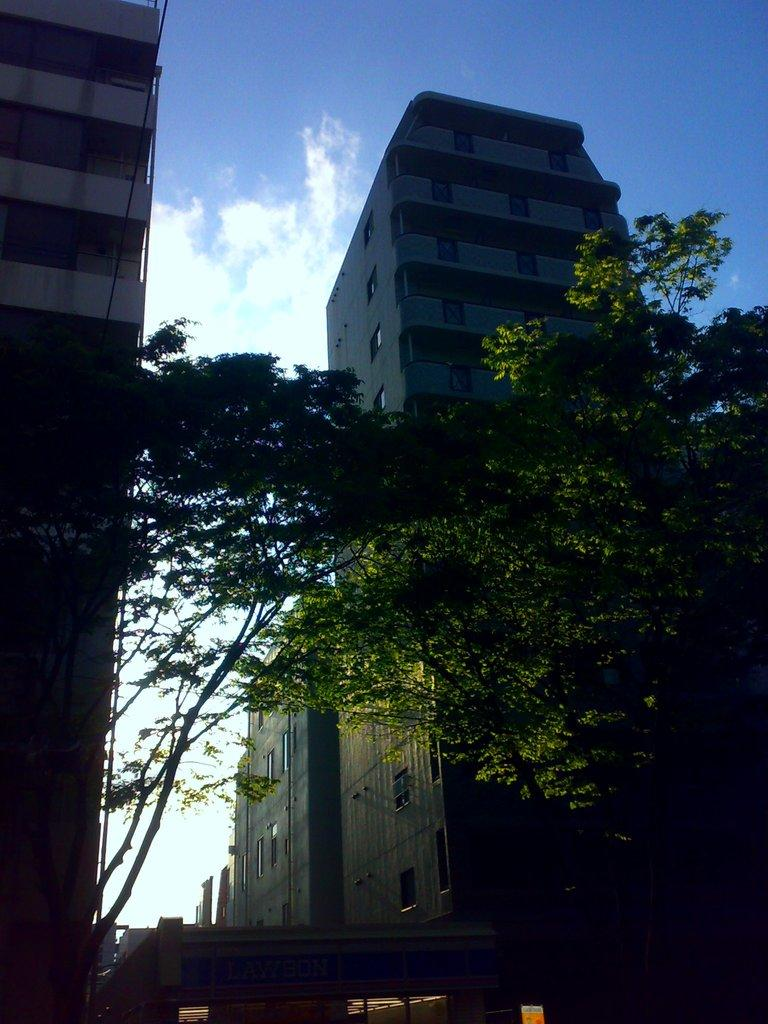What type of living organisms can be seen in the image? Plants can be seen in the image. What is the color of the plants in the image? The plants are green in color. What type of man-made structures are visible in the image? Buildings are visible in the image. What is on the ground in the image? There is a vehicle on the ground in the image. What part of the natural environment is visible in the image? The sky is visible in the background of the image. What type of window can be seen in the image? There is no window present in the image. What suggestion is being made by the plants in the image? Plants do not make suggestions; they are living organisms that do not have the ability to communicate in this way. 